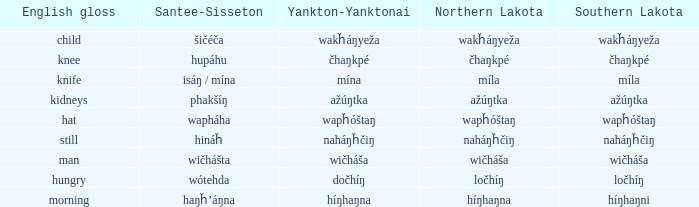Name the english gloss for haŋȟ’áŋna Morning. 